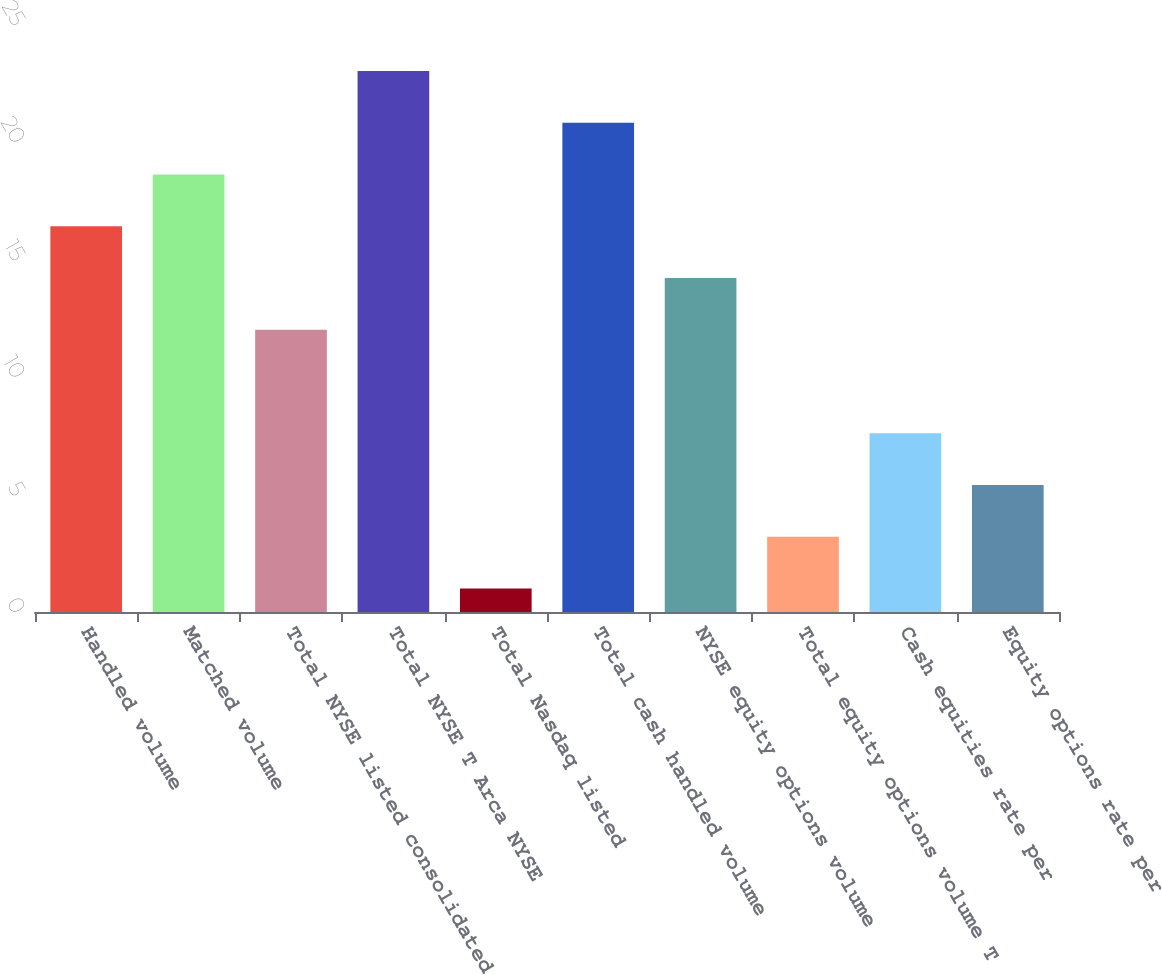Convert chart. <chart><loc_0><loc_0><loc_500><loc_500><bar_chart><fcel>Handled volume<fcel>Matched volume<fcel>Total NYSE listed consolidated<fcel>Total NYSE T Arca NYSE<fcel>Total Nasdaq listed<fcel>Total cash handled volume<fcel>NYSE equity options volume<fcel>Total equity options volume T<fcel>Cash equities rate per<fcel>Equity options rate per<nl><fcel>16.4<fcel>18.6<fcel>12<fcel>23<fcel>1<fcel>20.8<fcel>14.2<fcel>3.2<fcel>7.6<fcel>5.4<nl></chart> 